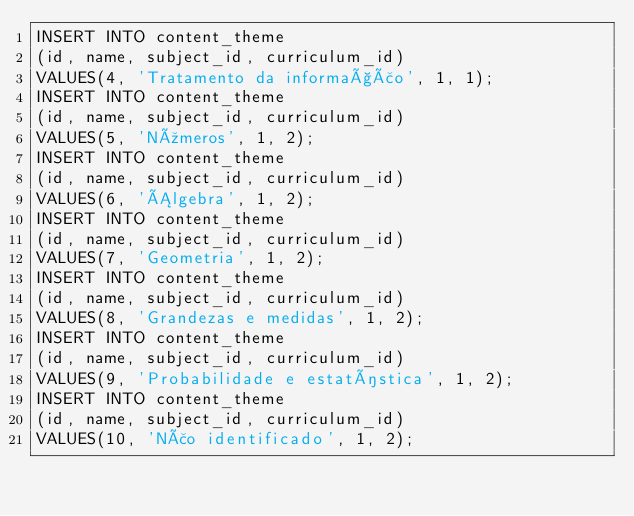<code> <loc_0><loc_0><loc_500><loc_500><_SQL_>INSERT INTO content_theme
(id, name, subject_id, curriculum_id)
VALUES(4, 'Tratamento da informação', 1, 1);
INSERT INTO content_theme
(id, name, subject_id, curriculum_id)
VALUES(5, 'Números', 1, 2);
INSERT INTO content_theme
(id, name, subject_id, curriculum_id)
VALUES(6, 'Álgebra', 1, 2);
INSERT INTO content_theme
(id, name, subject_id, curriculum_id)
VALUES(7, 'Geometria', 1, 2);
INSERT INTO content_theme
(id, name, subject_id, curriculum_id)
VALUES(8, 'Grandezas e medidas', 1, 2);
INSERT INTO content_theme
(id, name, subject_id, curriculum_id)
VALUES(9, 'Probabilidade e estatística', 1, 2);
INSERT INTO content_theme
(id, name, subject_id, curriculum_id)
VALUES(10, 'Não identificado', 1, 2);
</code> 